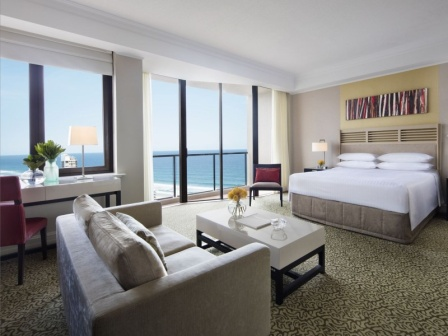Can you describe the main features of this image for me? The image captures a spacious and luxurious hotel room with a peaceful ambiance. The focal point is a large window that spans almost the entire wall, offering a breathtaking view of the ocean and a balcony that beckons for relaxation. 

To the right, a well-made bed with pristine white linens and a gray headboard is highlighted. Above it, a vibrant abstract painting injects a pop of color into the serene setting. 

In the center, a comfortable gray sofa faces a sleek white coffee table, creating an inviting seating area. To the left, a cozy red armchair, positioned next to a white side table and a lamp, provides a perfect nook for reading. 

A stylish black and white patterned carpet adds a layer of elegance to the room's overall decor. The coherent and thoughtful arrangement of furniture along with the harmonious color scheme create a welcoming environment that is both chic and relaxing. 